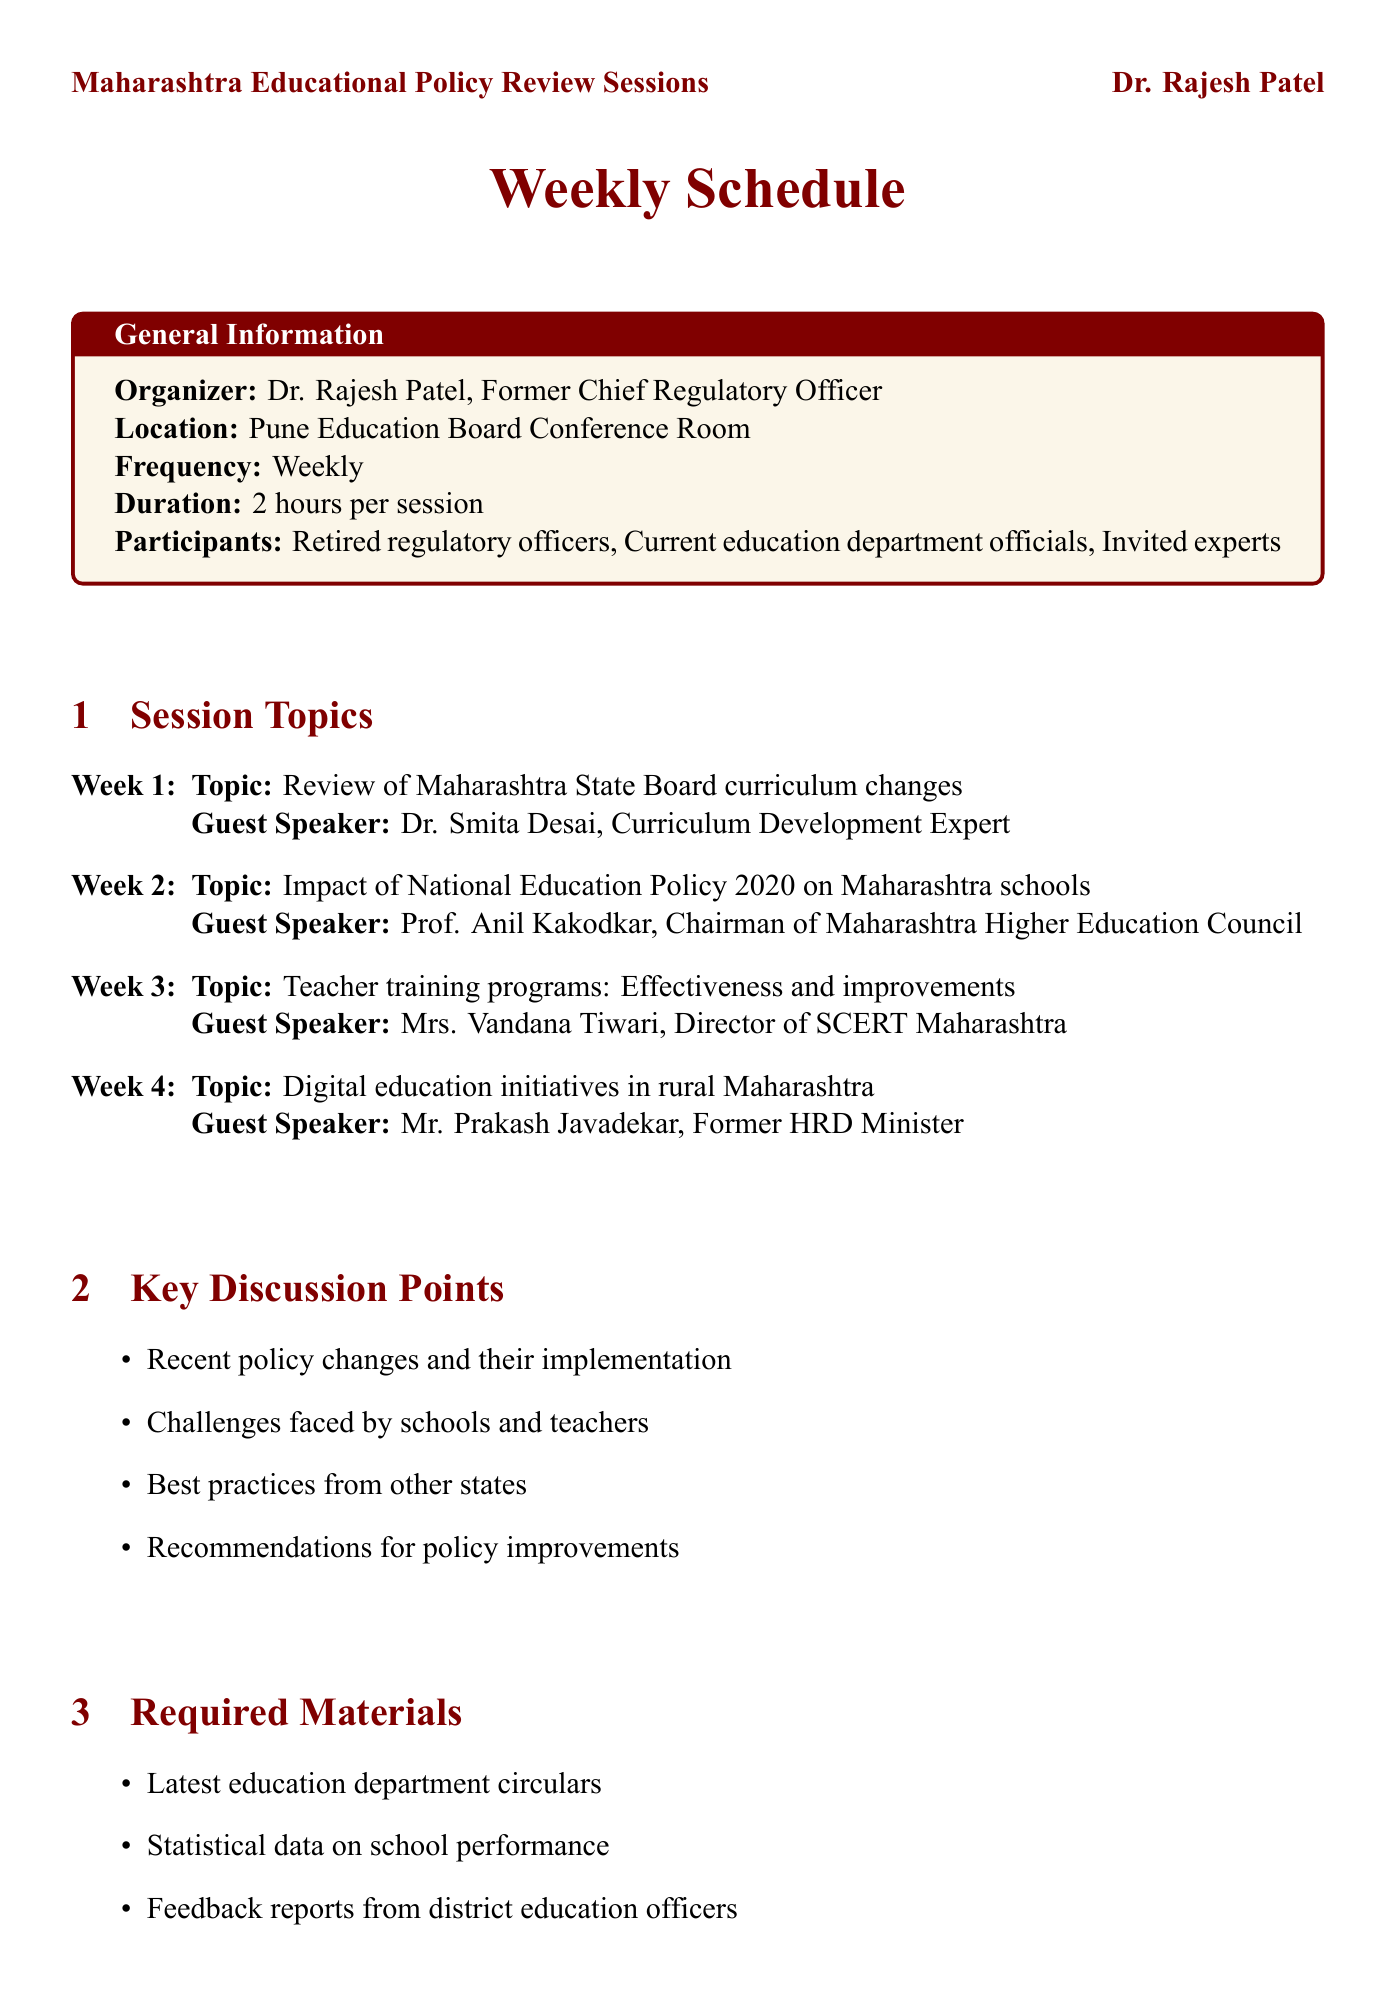What is the organizer's name? The organizer is identified at the beginning of the document, which states the name as Dr. Rajesh Patel.
Answer: Dr. Rajesh Patel How long is each session scheduled to last? The duration of each session is explicitly mentioned in the general information section of the document.
Answer: 2 hours Who is the guest speaker for Week 3? The guest speaker for Week 3 is specified in the session topics, pointing to Mrs. Vandana Tiwari.
Answer: Mrs. Vandana Tiwari What is the first topic of discussion? The first topic is listed in the session topics section, which specifically mentions it as "Review of Maharashtra State Board curriculum changes."
Answer: Review of Maharashtra State Board curriculum changes How many key discussion points are listed? The number of key discussion points can be counted from the itemized list in that section of the document.
Answer: 4 What is one of the required materials for the sessions? The required materials are directly listed, any item can be an answer; one of them is specified as "Latest education department circulars."
Answer: Latest education department circulars What type of participants are included in the sessions? Various participant types are outlined in the general information section of the document.
Answer: Retired regulatory officers What action is planned to follow the sessions? Follow-up actions are mentioned in their respective section, listing the activities to be undertaken after the sessions.
Answer: Compile session summaries What special consideration is mentioned for senior participants? The document lists various special considerations, which include ensuring accessibility for senior participants.
Answer: Ensure accessibility for senior participants 